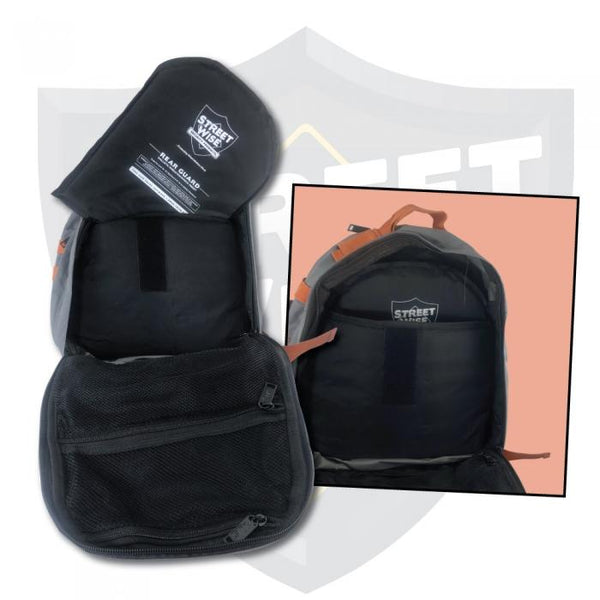Imagine this backpack in a futuristic setting. Describe an advanced feature it might have in the future and its usage. In a futuristic setting, this backpack could feature integrated solar panels and a built-in battery pack, allowing users to charge their electronic devices on the go. It might also come with a smart fabric that can adapt to weather conditions, becoming more breathable or insulating as necessary. Additionally, an augmented reality (AR) screen could be embedded into the backpack strap, providing navigation, fitness tracking, and real-time alerts about surroundings, enhancing the safety and convenience for users in a variety of environments. 